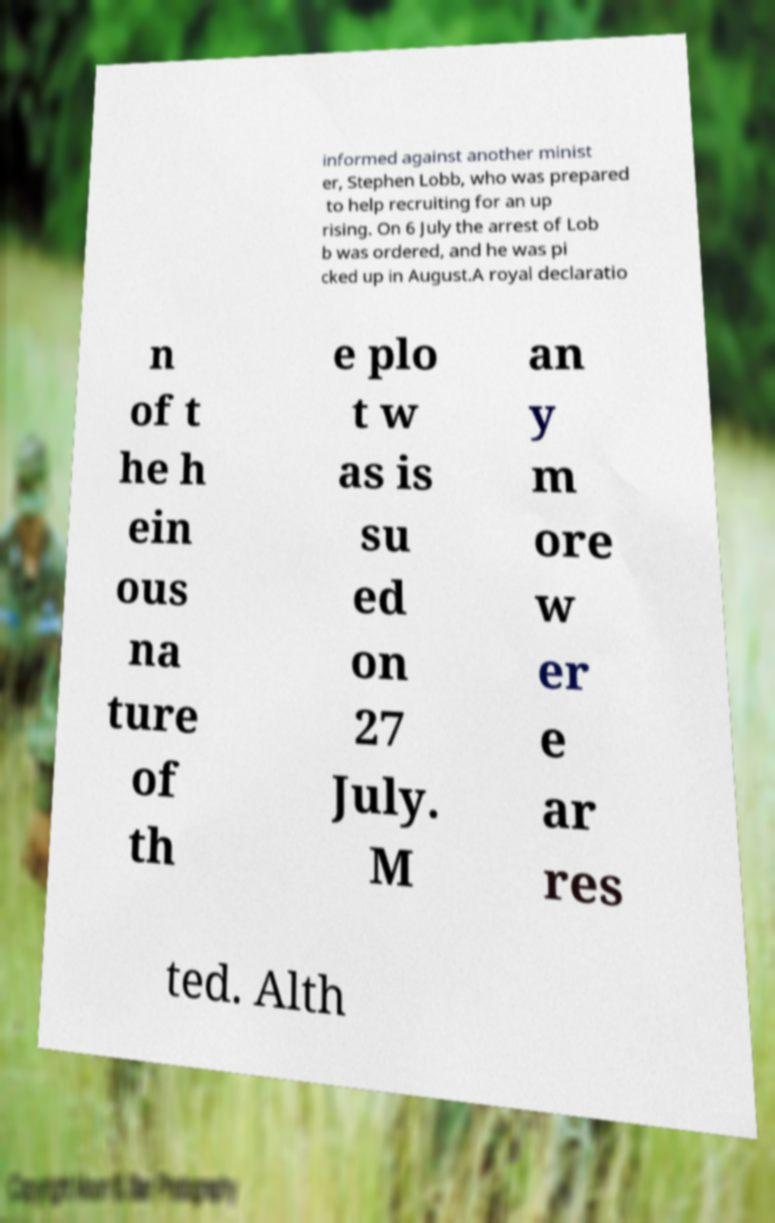Could you extract and type out the text from this image? informed against another minist er, Stephen Lobb, who was prepared to help recruiting for an up rising. On 6 July the arrest of Lob b was ordered, and he was pi cked up in August.A royal declaratio n of t he h ein ous na ture of th e plo t w as is su ed on 27 July. M an y m ore w er e ar res ted. Alth 